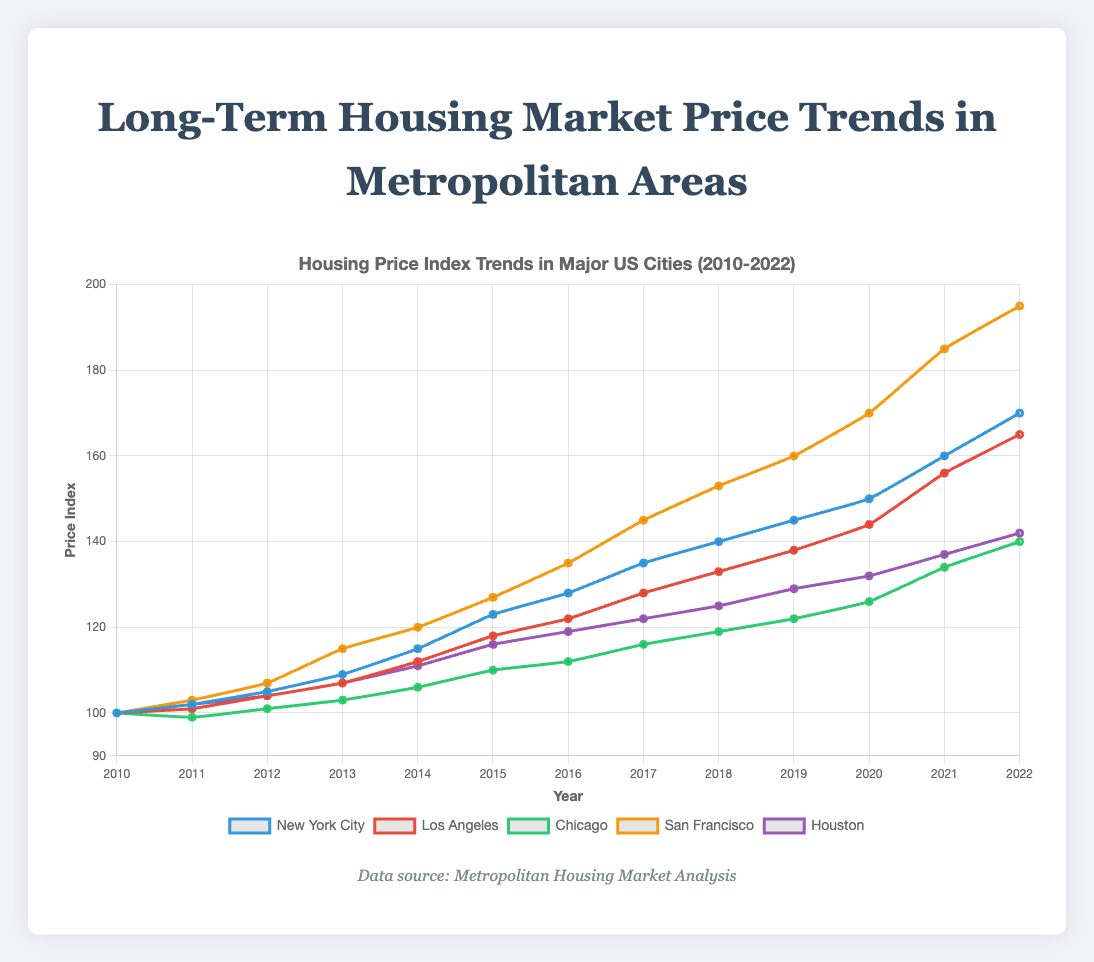Which city had the highest Price Index in 2022? San Francisco had the highest Price Index in 2022, with a value of 195. By checking the Price Index values for each city in 2022, San Francisco’s value is the largest.
Answer: San Francisco How much did the Price Index increase in Los Angeles from 2010 to 2022? The increase is calculated by subtracting the 2010 Price Index from the 2022 Price Index: 165 (2022) - 100 (2010). Therefore, the increase was 65.
Answer: 65 Which city showed the smallest growth in the Price Index from 2010 to 2022? Chicago showed the smallest growth. The Price Index in Chicago grew from 100 in 2010 to 140 in 2022, an increase of 40 points. Other cities had higher growth.
Answer: Chicago Which cities had a Price Index greater than 150 in 2022? By inspecting the 2022 Price Index values, New York City (170), Los Angeles (165), and San Francisco (195) had values greater than 150, while Chicago and Houston did not.
Answer: New York City, Los Angeles, San Francisco What is the average Price Index for Houston between 2015 and 2020? The average is calculated by summing the Price Index values for Houston from 2015 to 2020 (116, 119, 122, 125, 129, 132) and dividing by the number of years. The sum is 743, and 743 / 6 is approximately 124.
Answer: 124 In which year did San Francisco surpass a Price Index of 150? San Francisco first surpassed a Price Index of 150 in 2018, with a value of 153. Checking the values year by year, San Francisco surpassed 150 between 2017 (145) and 2018 (153).
Answer: 2018 Compare the Price Index growth rate of New York City and Los Angeles from 2010 to 2015. Which had a higher growth rate? New York City's growth from 2010 (100) to 2015 (123) is 23 points. Los Angeles grew from 100 in 2010 to 118 in 2015, an increase of 18 points. Thus, New York City had a higher growth rate in this period.
Answer: New York City Was Houston’s Price Index consistently increasing every year from 2010 to 2022? Inspecting the Houston data, the Price Index increased every year from 2010 to 2022 without any decline, confirming a consistent increase.
Answer: Yes What is the median Price Index value for Chicago from 2010 to 2022? To find the median, order the values from lowest to highest: (99, 100, 101, 103, 106, 110, 112, 116, 119, 122, 126, 134, 140). The median is the middle value, which for 13 values is the 7th value: 112.
Answer: 112 Which two cities had the closest Price Index values in 2020? The closest values in 2020 are between New York City (150) and San Francisco (170), or Chicago (126) and Houston (132). The difference between Chicago and Houston is 6, while between New York City and San Francisco is 20. Therefore, Chicago and Houston had the closest values.
Answer: Chicago and Houston 